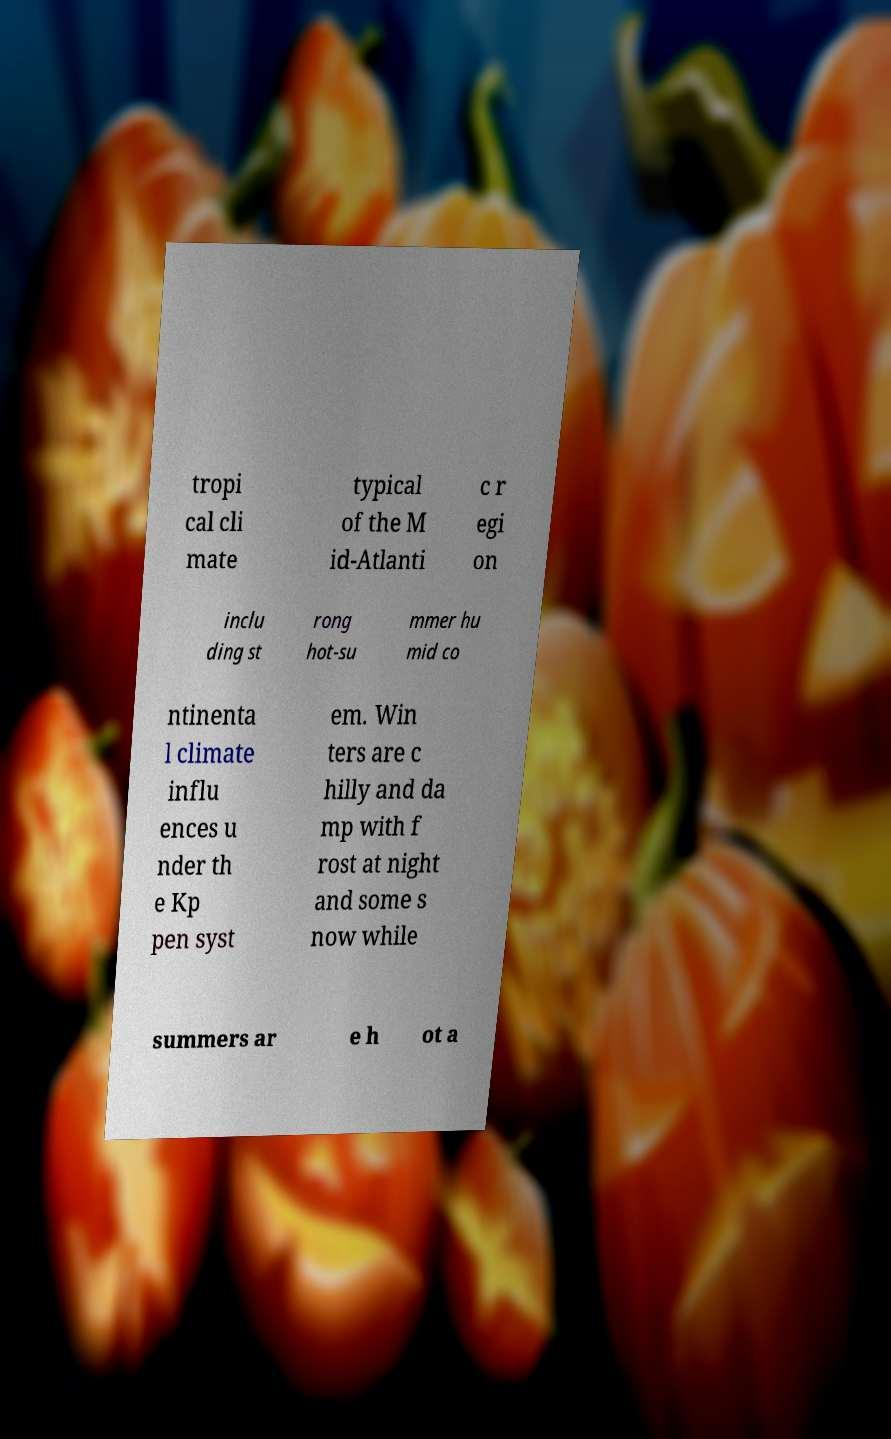I need the written content from this picture converted into text. Can you do that? tropi cal cli mate typical of the M id-Atlanti c r egi on inclu ding st rong hot-su mmer hu mid co ntinenta l climate influ ences u nder th e Kp pen syst em. Win ters are c hilly and da mp with f rost at night and some s now while summers ar e h ot a 